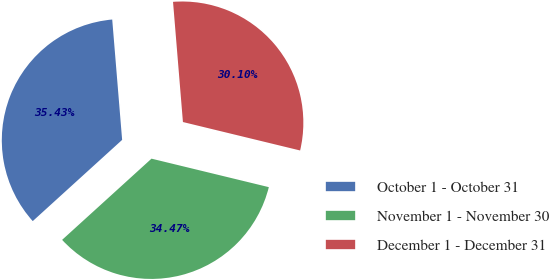<chart> <loc_0><loc_0><loc_500><loc_500><pie_chart><fcel>October 1 - October 31<fcel>November 1 - November 30<fcel>December 1 - December 31<nl><fcel>35.43%<fcel>34.47%<fcel>30.1%<nl></chart> 